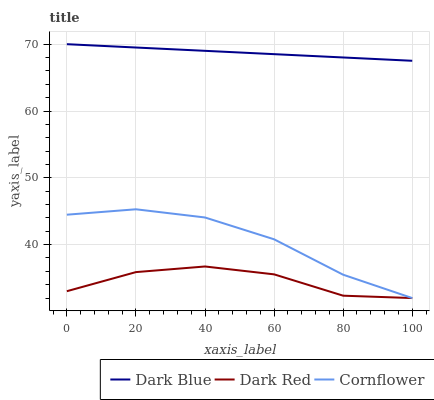Does Dark Red have the minimum area under the curve?
Answer yes or no. Yes. Does Dark Blue have the maximum area under the curve?
Answer yes or no. Yes. Does Cornflower have the minimum area under the curve?
Answer yes or no. No. Does Cornflower have the maximum area under the curve?
Answer yes or no. No. Is Dark Blue the smoothest?
Answer yes or no. Yes. Is Dark Red the roughest?
Answer yes or no. Yes. Is Cornflower the smoothest?
Answer yes or no. No. Is Cornflower the roughest?
Answer yes or no. No. Does Dark Blue have the highest value?
Answer yes or no. Yes. Does Cornflower have the highest value?
Answer yes or no. No. Is Dark Red less than Dark Blue?
Answer yes or no. Yes. Is Dark Blue greater than Cornflower?
Answer yes or no. Yes. Does Cornflower intersect Dark Red?
Answer yes or no. Yes. Is Cornflower less than Dark Red?
Answer yes or no. No. Is Cornflower greater than Dark Red?
Answer yes or no. No. Does Dark Red intersect Dark Blue?
Answer yes or no. No. 